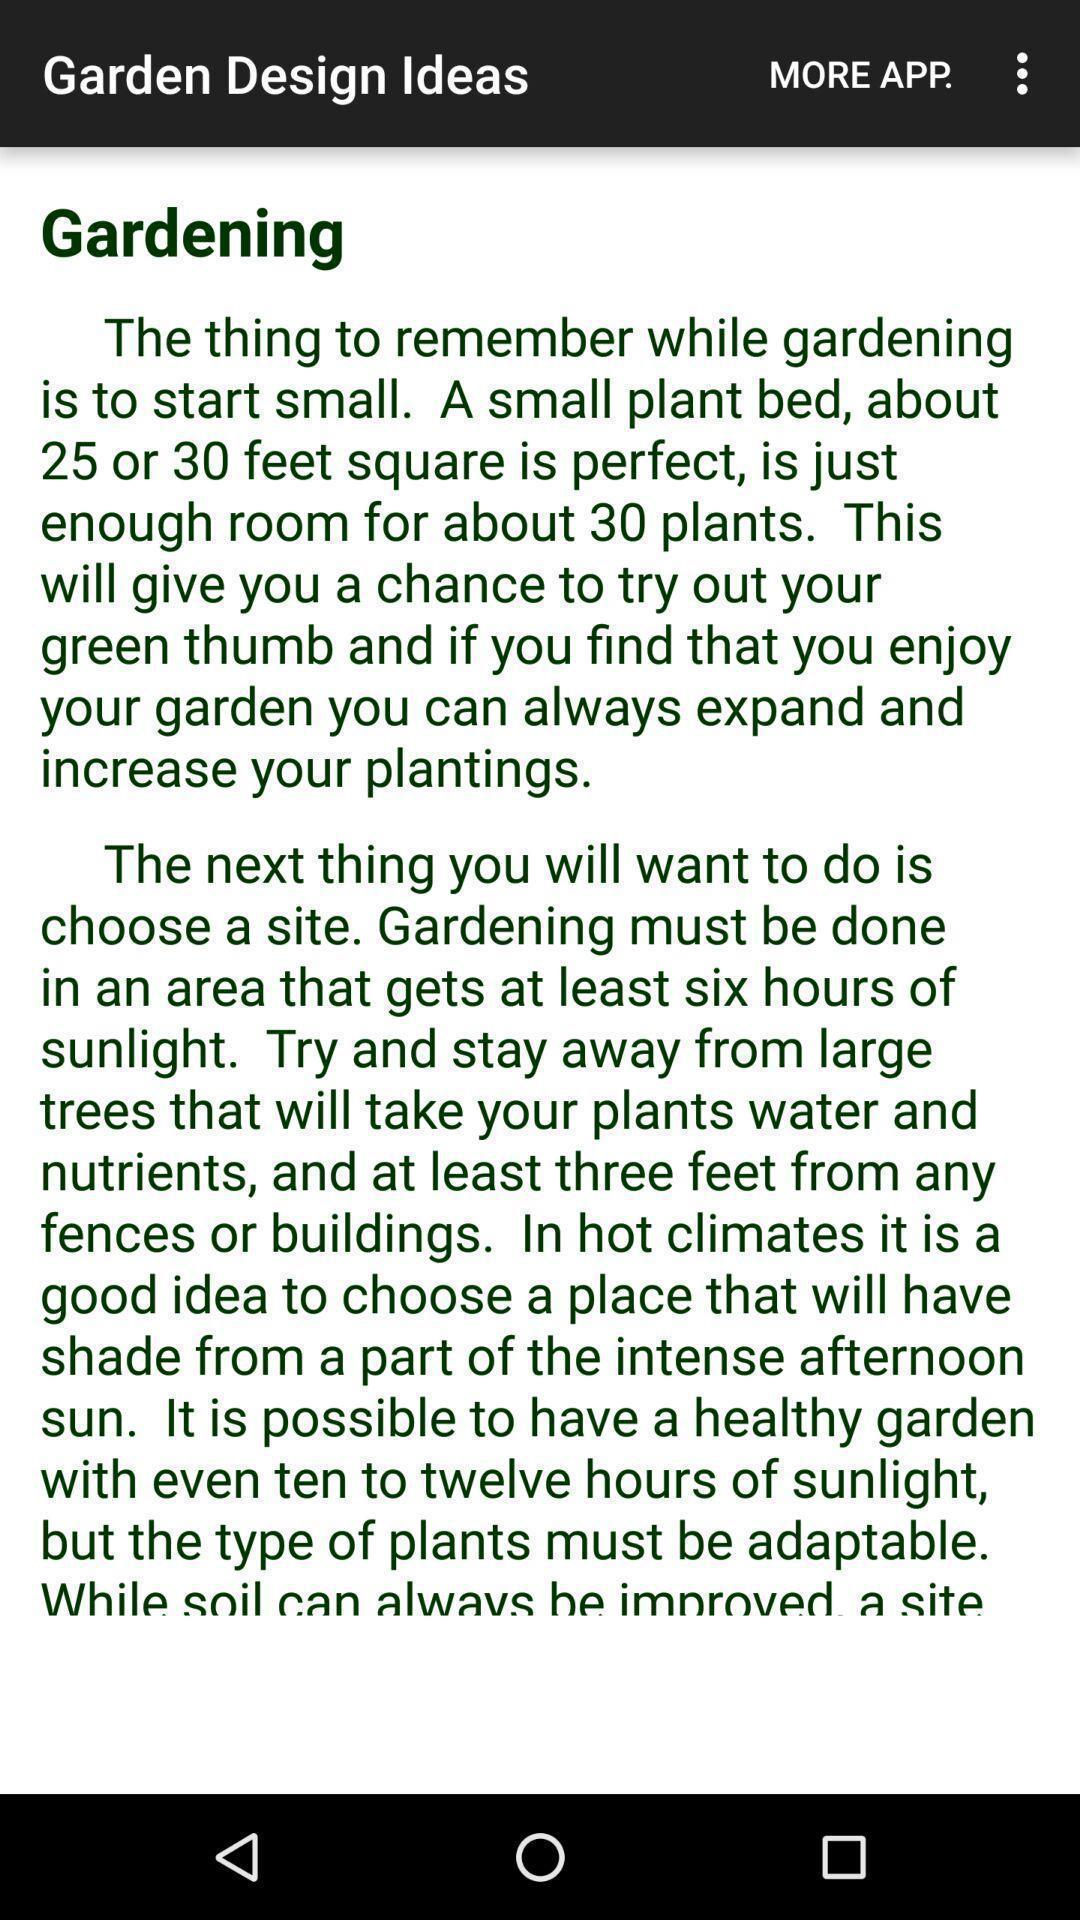Provide a description of this screenshot. Page displaying list of words in app. 